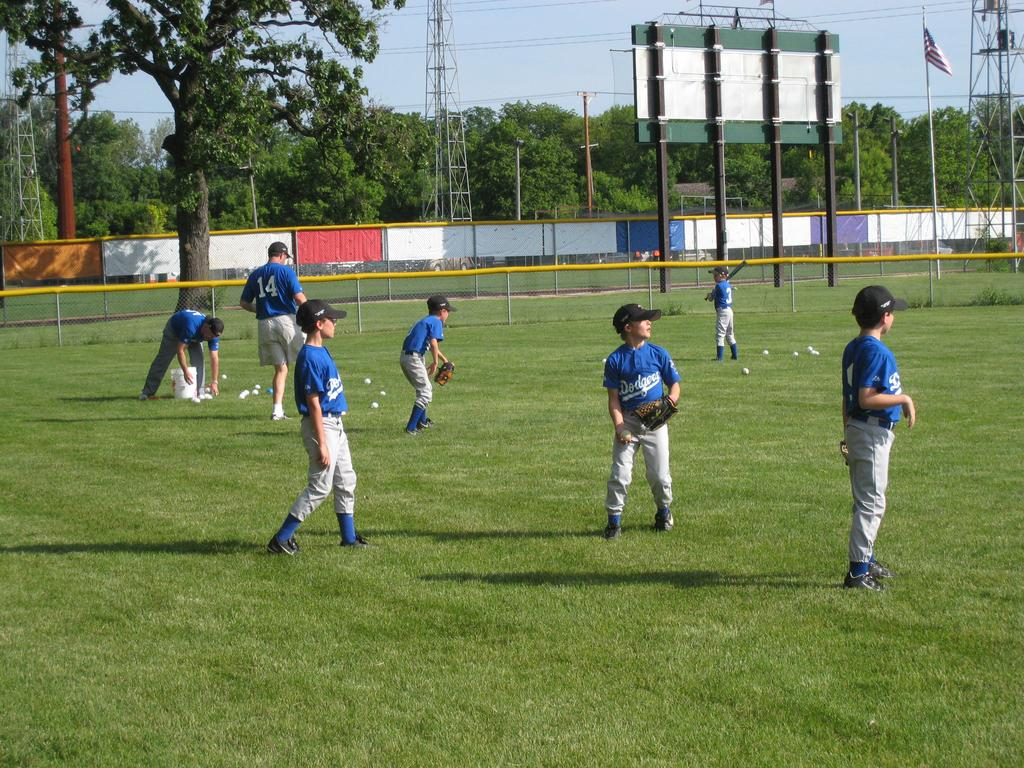<image>
Give a short and clear explanation of the subsequent image. Several children wearing blue and gray baseball uniforms with the logo for the dodgers on their chests. 